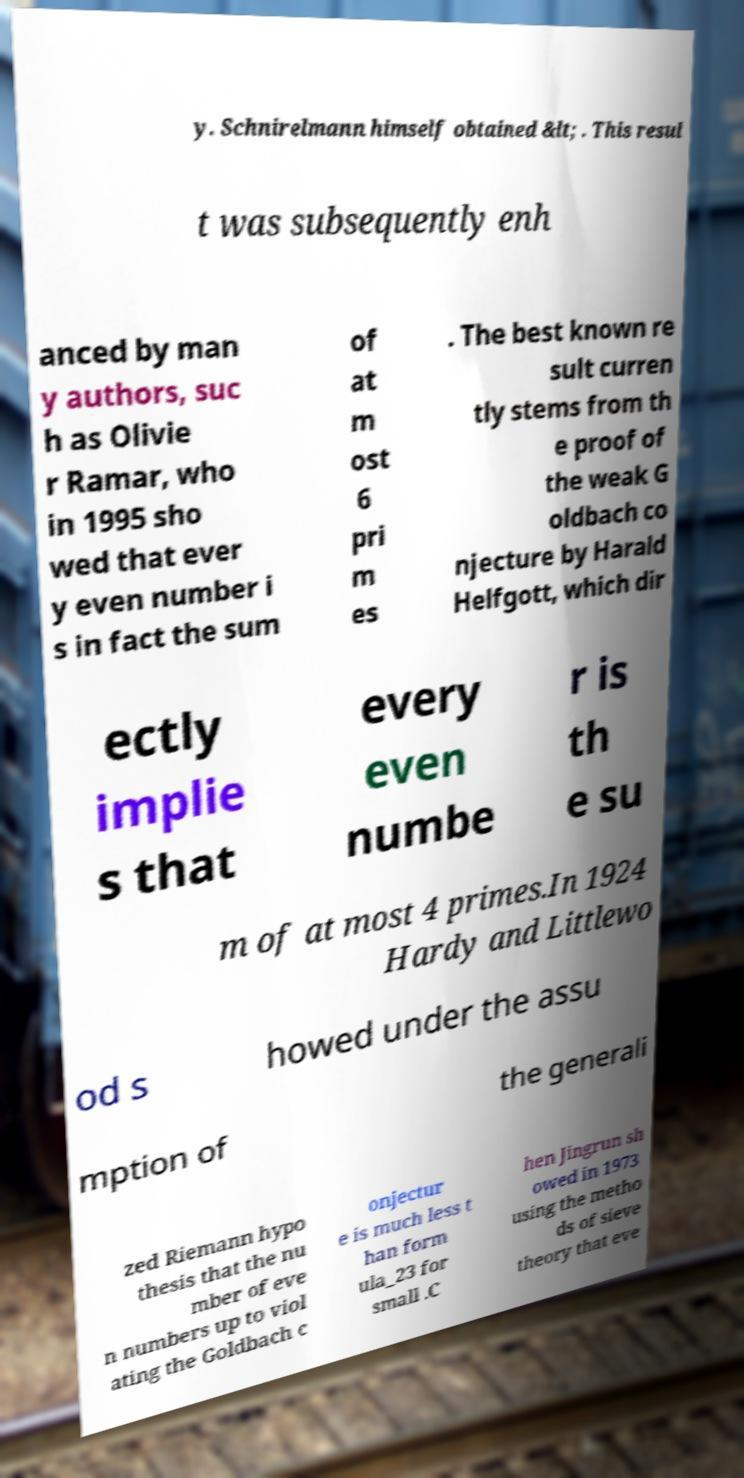Can you accurately transcribe the text from the provided image for me? y. Schnirelmann himself obtained &lt; . This resul t was subsequently enh anced by man y authors, suc h as Olivie r Ramar, who in 1995 sho wed that ever y even number i s in fact the sum of at m ost 6 pri m es . The best known re sult curren tly stems from th e proof of the weak G oldbach co njecture by Harald Helfgott, which dir ectly implie s that every even numbe r is th e su m of at most 4 primes.In 1924 Hardy and Littlewo od s howed under the assu mption of the generali zed Riemann hypo thesis that the nu mber of eve n numbers up to viol ating the Goldbach c onjectur e is much less t han form ula_23 for small .C hen Jingrun sh owed in 1973 using the metho ds of sieve theory that eve 